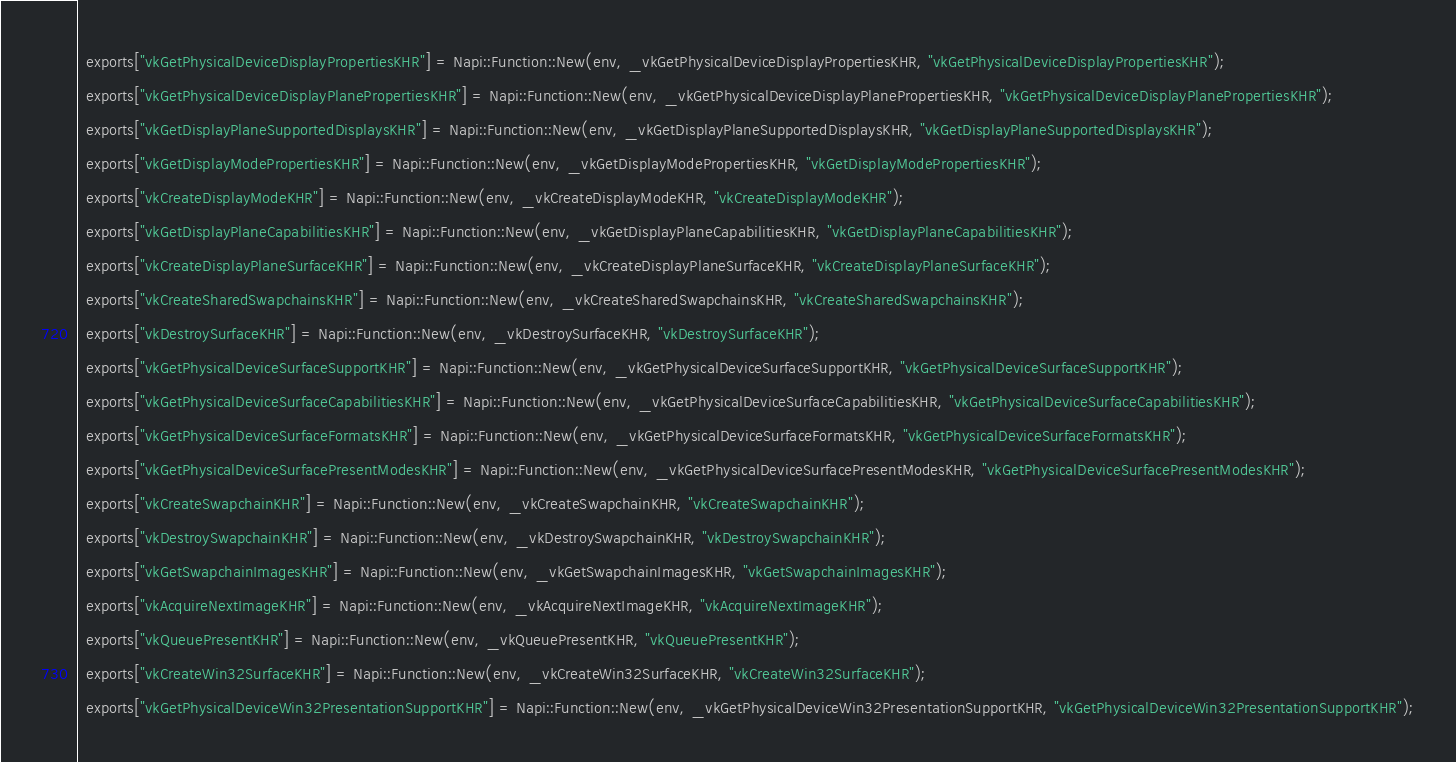<code> <loc_0><loc_0><loc_500><loc_500><_C++_>  exports["vkGetPhysicalDeviceDisplayPropertiesKHR"] = Napi::Function::New(env, _vkGetPhysicalDeviceDisplayPropertiesKHR, "vkGetPhysicalDeviceDisplayPropertiesKHR");
  exports["vkGetPhysicalDeviceDisplayPlanePropertiesKHR"] = Napi::Function::New(env, _vkGetPhysicalDeviceDisplayPlanePropertiesKHR, "vkGetPhysicalDeviceDisplayPlanePropertiesKHR");
  exports["vkGetDisplayPlaneSupportedDisplaysKHR"] = Napi::Function::New(env, _vkGetDisplayPlaneSupportedDisplaysKHR, "vkGetDisplayPlaneSupportedDisplaysKHR");
  exports["vkGetDisplayModePropertiesKHR"] = Napi::Function::New(env, _vkGetDisplayModePropertiesKHR, "vkGetDisplayModePropertiesKHR");
  exports["vkCreateDisplayModeKHR"] = Napi::Function::New(env, _vkCreateDisplayModeKHR, "vkCreateDisplayModeKHR");
  exports["vkGetDisplayPlaneCapabilitiesKHR"] = Napi::Function::New(env, _vkGetDisplayPlaneCapabilitiesKHR, "vkGetDisplayPlaneCapabilitiesKHR");
  exports["vkCreateDisplayPlaneSurfaceKHR"] = Napi::Function::New(env, _vkCreateDisplayPlaneSurfaceKHR, "vkCreateDisplayPlaneSurfaceKHR");
  exports["vkCreateSharedSwapchainsKHR"] = Napi::Function::New(env, _vkCreateSharedSwapchainsKHR, "vkCreateSharedSwapchainsKHR");
  exports["vkDestroySurfaceKHR"] = Napi::Function::New(env, _vkDestroySurfaceKHR, "vkDestroySurfaceKHR");
  exports["vkGetPhysicalDeviceSurfaceSupportKHR"] = Napi::Function::New(env, _vkGetPhysicalDeviceSurfaceSupportKHR, "vkGetPhysicalDeviceSurfaceSupportKHR");
  exports["vkGetPhysicalDeviceSurfaceCapabilitiesKHR"] = Napi::Function::New(env, _vkGetPhysicalDeviceSurfaceCapabilitiesKHR, "vkGetPhysicalDeviceSurfaceCapabilitiesKHR");
  exports["vkGetPhysicalDeviceSurfaceFormatsKHR"] = Napi::Function::New(env, _vkGetPhysicalDeviceSurfaceFormatsKHR, "vkGetPhysicalDeviceSurfaceFormatsKHR");
  exports["vkGetPhysicalDeviceSurfacePresentModesKHR"] = Napi::Function::New(env, _vkGetPhysicalDeviceSurfacePresentModesKHR, "vkGetPhysicalDeviceSurfacePresentModesKHR");
  exports["vkCreateSwapchainKHR"] = Napi::Function::New(env, _vkCreateSwapchainKHR, "vkCreateSwapchainKHR");
  exports["vkDestroySwapchainKHR"] = Napi::Function::New(env, _vkDestroySwapchainKHR, "vkDestroySwapchainKHR");
  exports["vkGetSwapchainImagesKHR"] = Napi::Function::New(env, _vkGetSwapchainImagesKHR, "vkGetSwapchainImagesKHR");
  exports["vkAcquireNextImageKHR"] = Napi::Function::New(env, _vkAcquireNextImageKHR, "vkAcquireNextImageKHR");
  exports["vkQueuePresentKHR"] = Napi::Function::New(env, _vkQueuePresentKHR, "vkQueuePresentKHR");
  exports["vkCreateWin32SurfaceKHR"] = Napi::Function::New(env, _vkCreateWin32SurfaceKHR, "vkCreateWin32SurfaceKHR");
  exports["vkGetPhysicalDeviceWin32PresentationSupportKHR"] = Napi::Function::New(env, _vkGetPhysicalDeviceWin32PresentationSupportKHR, "vkGetPhysicalDeviceWin32PresentationSupportKHR");</code> 